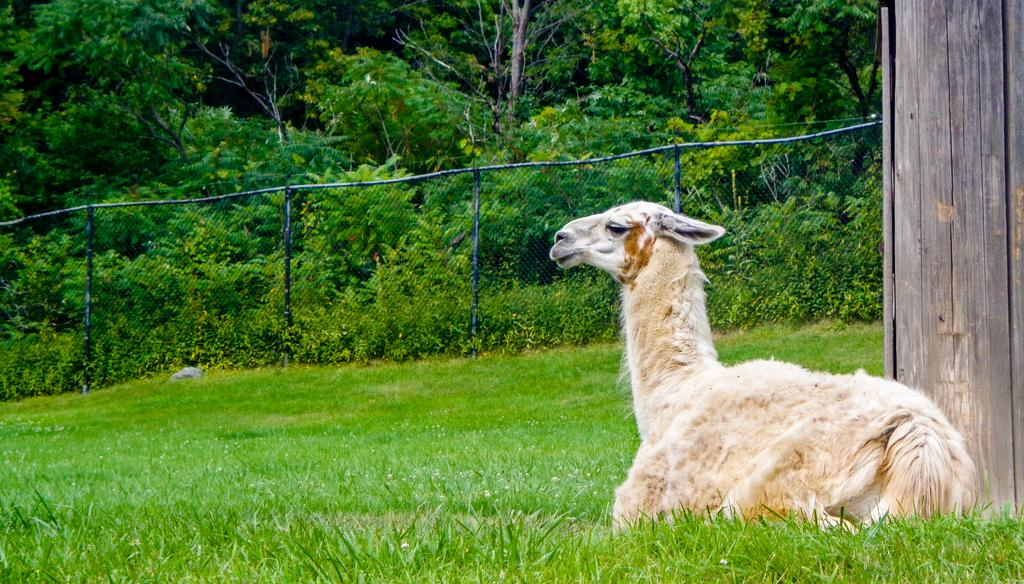What type of animal is in the image? There is a baby camel in the image. What color is the baby camel? The baby camel is brown in color. What can be seen in the background of the image? There is fencing and trees in the background of the image. Is there a giraffe smoking a cart in the image? No, there is no giraffe or cart present in the image, and no one is smoking. 